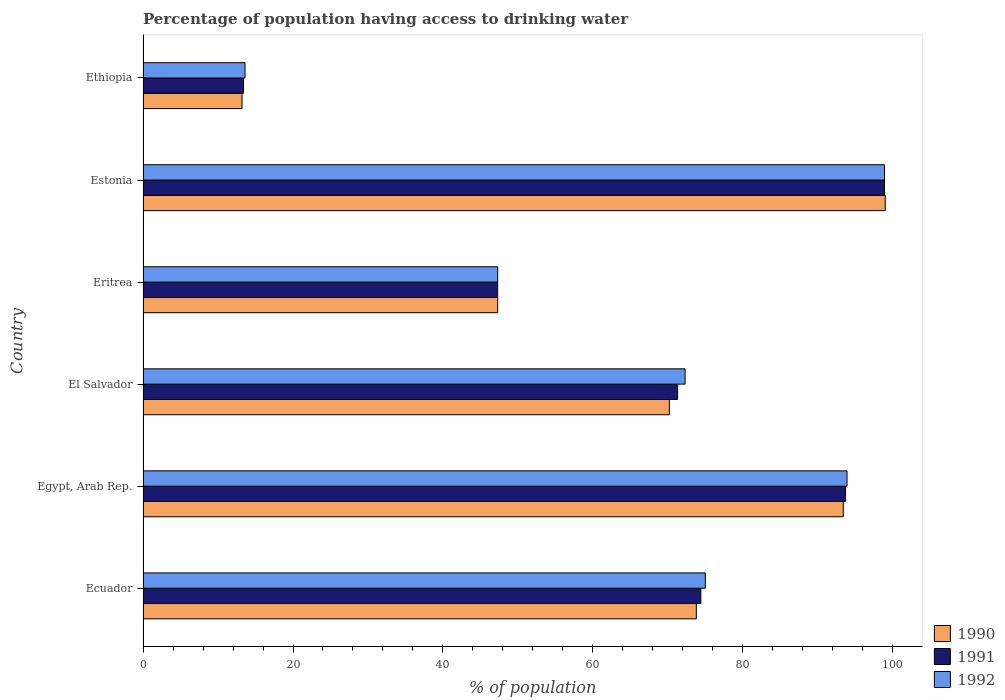How many groups of bars are there?
Give a very brief answer. 6. Are the number of bars per tick equal to the number of legend labels?
Ensure brevity in your answer.  Yes. How many bars are there on the 5th tick from the top?
Provide a succinct answer. 3. What is the label of the 6th group of bars from the top?
Ensure brevity in your answer.  Ecuador. In how many cases, is the number of bars for a given country not equal to the number of legend labels?
Offer a terse response. 0. What is the percentage of population having access to drinking water in 1991 in Estonia?
Your answer should be very brief. 98.9. Across all countries, what is the maximum percentage of population having access to drinking water in 1992?
Your response must be concise. 98.9. Across all countries, what is the minimum percentage of population having access to drinking water in 1990?
Give a very brief answer. 13.2. In which country was the percentage of population having access to drinking water in 1992 maximum?
Offer a terse response. Estonia. In which country was the percentage of population having access to drinking water in 1991 minimum?
Your response must be concise. Ethiopia. What is the total percentage of population having access to drinking water in 1992 in the graph?
Keep it short and to the point. 401. What is the difference between the percentage of population having access to drinking water in 1991 in Ecuador and that in Eritrea?
Offer a terse response. 27.1. What is the difference between the percentage of population having access to drinking water in 1991 in El Salvador and the percentage of population having access to drinking water in 1990 in Ecuador?
Your response must be concise. -2.5. What is the average percentage of population having access to drinking water in 1992 per country?
Your answer should be very brief. 66.83. What is the difference between the percentage of population having access to drinking water in 1990 and percentage of population having access to drinking water in 1992 in Egypt, Arab Rep.?
Make the answer very short. -0.5. In how many countries, is the percentage of population having access to drinking water in 1992 greater than 84 %?
Provide a short and direct response. 2. What is the ratio of the percentage of population having access to drinking water in 1990 in Egypt, Arab Rep. to that in Ethiopia?
Offer a very short reply. 7.08. Is the difference between the percentage of population having access to drinking water in 1990 in El Salvador and Eritrea greater than the difference between the percentage of population having access to drinking water in 1992 in El Salvador and Eritrea?
Offer a very short reply. No. What is the difference between the highest and the lowest percentage of population having access to drinking water in 1992?
Ensure brevity in your answer.  85.3. Are all the bars in the graph horizontal?
Provide a short and direct response. Yes. How many countries are there in the graph?
Your answer should be compact. 6. What is the difference between two consecutive major ticks on the X-axis?
Your answer should be compact. 20. Are the values on the major ticks of X-axis written in scientific E-notation?
Provide a short and direct response. No. Does the graph contain any zero values?
Your response must be concise. No. Does the graph contain grids?
Offer a terse response. No. How many legend labels are there?
Offer a very short reply. 3. What is the title of the graph?
Keep it short and to the point. Percentage of population having access to drinking water. What is the label or title of the X-axis?
Give a very brief answer. % of population. What is the label or title of the Y-axis?
Provide a short and direct response. Country. What is the % of population in 1990 in Ecuador?
Make the answer very short. 73.8. What is the % of population of 1991 in Ecuador?
Give a very brief answer. 74.4. What is the % of population in 1992 in Ecuador?
Offer a very short reply. 75. What is the % of population in 1990 in Egypt, Arab Rep.?
Your answer should be compact. 93.4. What is the % of population of 1991 in Egypt, Arab Rep.?
Offer a terse response. 93.7. What is the % of population in 1992 in Egypt, Arab Rep.?
Give a very brief answer. 93.9. What is the % of population in 1990 in El Salvador?
Provide a short and direct response. 70.2. What is the % of population in 1991 in El Salvador?
Your response must be concise. 71.3. What is the % of population in 1992 in El Salvador?
Provide a short and direct response. 72.3. What is the % of population of 1990 in Eritrea?
Make the answer very short. 47.3. What is the % of population in 1991 in Eritrea?
Offer a terse response. 47.3. What is the % of population in 1992 in Eritrea?
Provide a short and direct response. 47.3. What is the % of population in 1991 in Estonia?
Your response must be concise. 98.9. What is the % of population in 1992 in Estonia?
Make the answer very short. 98.9. What is the % of population of 1990 in Ethiopia?
Your answer should be very brief. 13.2. What is the % of population in 1992 in Ethiopia?
Keep it short and to the point. 13.6. Across all countries, what is the maximum % of population in 1990?
Your answer should be very brief. 99. Across all countries, what is the maximum % of population in 1991?
Offer a terse response. 98.9. Across all countries, what is the maximum % of population in 1992?
Give a very brief answer. 98.9. Across all countries, what is the minimum % of population of 1991?
Your answer should be compact. 13.4. Across all countries, what is the minimum % of population of 1992?
Ensure brevity in your answer.  13.6. What is the total % of population in 1990 in the graph?
Your answer should be compact. 396.9. What is the total % of population in 1991 in the graph?
Provide a succinct answer. 399. What is the total % of population of 1992 in the graph?
Your response must be concise. 401. What is the difference between the % of population in 1990 in Ecuador and that in Egypt, Arab Rep.?
Give a very brief answer. -19.6. What is the difference between the % of population in 1991 in Ecuador and that in Egypt, Arab Rep.?
Ensure brevity in your answer.  -19.3. What is the difference between the % of population in 1992 in Ecuador and that in Egypt, Arab Rep.?
Your response must be concise. -18.9. What is the difference between the % of population of 1991 in Ecuador and that in Eritrea?
Provide a short and direct response. 27.1. What is the difference between the % of population in 1992 in Ecuador and that in Eritrea?
Your answer should be compact. 27.7. What is the difference between the % of population of 1990 in Ecuador and that in Estonia?
Offer a terse response. -25.2. What is the difference between the % of population in 1991 in Ecuador and that in Estonia?
Keep it short and to the point. -24.5. What is the difference between the % of population of 1992 in Ecuador and that in Estonia?
Give a very brief answer. -23.9. What is the difference between the % of population in 1990 in Ecuador and that in Ethiopia?
Provide a short and direct response. 60.6. What is the difference between the % of population in 1992 in Ecuador and that in Ethiopia?
Provide a short and direct response. 61.4. What is the difference between the % of population in 1990 in Egypt, Arab Rep. and that in El Salvador?
Your answer should be compact. 23.2. What is the difference between the % of population of 1991 in Egypt, Arab Rep. and that in El Salvador?
Make the answer very short. 22.4. What is the difference between the % of population in 1992 in Egypt, Arab Rep. and that in El Salvador?
Make the answer very short. 21.6. What is the difference between the % of population in 1990 in Egypt, Arab Rep. and that in Eritrea?
Ensure brevity in your answer.  46.1. What is the difference between the % of population of 1991 in Egypt, Arab Rep. and that in Eritrea?
Offer a very short reply. 46.4. What is the difference between the % of population in 1992 in Egypt, Arab Rep. and that in Eritrea?
Ensure brevity in your answer.  46.6. What is the difference between the % of population of 1991 in Egypt, Arab Rep. and that in Estonia?
Your answer should be very brief. -5.2. What is the difference between the % of population in 1990 in Egypt, Arab Rep. and that in Ethiopia?
Your answer should be compact. 80.2. What is the difference between the % of population in 1991 in Egypt, Arab Rep. and that in Ethiopia?
Provide a succinct answer. 80.3. What is the difference between the % of population in 1992 in Egypt, Arab Rep. and that in Ethiopia?
Offer a terse response. 80.3. What is the difference between the % of population of 1990 in El Salvador and that in Eritrea?
Your answer should be very brief. 22.9. What is the difference between the % of population in 1991 in El Salvador and that in Eritrea?
Offer a very short reply. 24. What is the difference between the % of population of 1992 in El Salvador and that in Eritrea?
Offer a terse response. 25. What is the difference between the % of population in 1990 in El Salvador and that in Estonia?
Offer a terse response. -28.8. What is the difference between the % of population of 1991 in El Salvador and that in Estonia?
Ensure brevity in your answer.  -27.6. What is the difference between the % of population of 1992 in El Salvador and that in Estonia?
Offer a terse response. -26.6. What is the difference between the % of population of 1990 in El Salvador and that in Ethiopia?
Offer a very short reply. 57. What is the difference between the % of population in 1991 in El Salvador and that in Ethiopia?
Keep it short and to the point. 57.9. What is the difference between the % of population of 1992 in El Salvador and that in Ethiopia?
Your answer should be compact. 58.7. What is the difference between the % of population in 1990 in Eritrea and that in Estonia?
Offer a terse response. -51.7. What is the difference between the % of population of 1991 in Eritrea and that in Estonia?
Provide a short and direct response. -51.6. What is the difference between the % of population of 1992 in Eritrea and that in Estonia?
Provide a succinct answer. -51.6. What is the difference between the % of population in 1990 in Eritrea and that in Ethiopia?
Ensure brevity in your answer.  34.1. What is the difference between the % of population of 1991 in Eritrea and that in Ethiopia?
Your response must be concise. 33.9. What is the difference between the % of population of 1992 in Eritrea and that in Ethiopia?
Your answer should be very brief. 33.7. What is the difference between the % of population in 1990 in Estonia and that in Ethiopia?
Your answer should be compact. 85.8. What is the difference between the % of population in 1991 in Estonia and that in Ethiopia?
Your response must be concise. 85.5. What is the difference between the % of population in 1992 in Estonia and that in Ethiopia?
Ensure brevity in your answer.  85.3. What is the difference between the % of population in 1990 in Ecuador and the % of population in 1991 in Egypt, Arab Rep.?
Provide a short and direct response. -19.9. What is the difference between the % of population of 1990 in Ecuador and the % of population of 1992 in Egypt, Arab Rep.?
Your answer should be very brief. -20.1. What is the difference between the % of population in 1991 in Ecuador and the % of population in 1992 in Egypt, Arab Rep.?
Provide a short and direct response. -19.5. What is the difference between the % of population of 1990 in Ecuador and the % of population of 1991 in El Salvador?
Your answer should be very brief. 2.5. What is the difference between the % of population in 1991 in Ecuador and the % of population in 1992 in El Salvador?
Your response must be concise. 2.1. What is the difference between the % of population in 1991 in Ecuador and the % of population in 1992 in Eritrea?
Offer a very short reply. 27.1. What is the difference between the % of population in 1990 in Ecuador and the % of population in 1991 in Estonia?
Your response must be concise. -25.1. What is the difference between the % of population of 1990 in Ecuador and the % of population of 1992 in Estonia?
Keep it short and to the point. -25.1. What is the difference between the % of population in 1991 in Ecuador and the % of population in 1992 in Estonia?
Make the answer very short. -24.5. What is the difference between the % of population of 1990 in Ecuador and the % of population of 1991 in Ethiopia?
Your response must be concise. 60.4. What is the difference between the % of population of 1990 in Ecuador and the % of population of 1992 in Ethiopia?
Ensure brevity in your answer.  60.2. What is the difference between the % of population in 1991 in Ecuador and the % of population in 1992 in Ethiopia?
Give a very brief answer. 60.8. What is the difference between the % of population in 1990 in Egypt, Arab Rep. and the % of population in 1991 in El Salvador?
Provide a short and direct response. 22.1. What is the difference between the % of population in 1990 in Egypt, Arab Rep. and the % of population in 1992 in El Salvador?
Offer a terse response. 21.1. What is the difference between the % of population in 1991 in Egypt, Arab Rep. and the % of population in 1992 in El Salvador?
Ensure brevity in your answer.  21.4. What is the difference between the % of population in 1990 in Egypt, Arab Rep. and the % of population in 1991 in Eritrea?
Offer a terse response. 46.1. What is the difference between the % of population in 1990 in Egypt, Arab Rep. and the % of population in 1992 in Eritrea?
Offer a very short reply. 46.1. What is the difference between the % of population in 1991 in Egypt, Arab Rep. and the % of population in 1992 in Eritrea?
Your response must be concise. 46.4. What is the difference between the % of population of 1990 in Egypt, Arab Rep. and the % of population of 1991 in Estonia?
Keep it short and to the point. -5.5. What is the difference between the % of population in 1990 in Egypt, Arab Rep. and the % of population in 1992 in Estonia?
Your answer should be very brief. -5.5. What is the difference between the % of population of 1990 in Egypt, Arab Rep. and the % of population of 1992 in Ethiopia?
Offer a very short reply. 79.8. What is the difference between the % of population in 1991 in Egypt, Arab Rep. and the % of population in 1992 in Ethiopia?
Offer a terse response. 80.1. What is the difference between the % of population in 1990 in El Salvador and the % of population in 1991 in Eritrea?
Your answer should be compact. 22.9. What is the difference between the % of population in 1990 in El Salvador and the % of population in 1992 in Eritrea?
Provide a succinct answer. 22.9. What is the difference between the % of population of 1991 in El Salvador and the % of population of 1992 in Eritrea?
Your answer should be compact. 24. What is the difference between the % of population in 1990 in El Salvador and the % of population in 1991 in Estonia?
Make the answer very short. -28.7. What is the difference between the % of population in 1990 in El Salvador and the % of population in 1992 in Estonia?
Offer a terse response. -28.7. What is the difference between the % of population in 1991 in El Salvador and the % of population in 1992 in Estonia?
Offer a very short reply. -27.6. What is the difference between the % of population in 1990 in El Salvador and the % of population in 1991 in Ethiopia?
Ensure brevity in your answer.  56.8. What is the difference between the % of population in 1990 in El Salvador and the % of population in 1992 in Ethiopia?
Your answer should be compact. 56.6. What is the difference between the % of population in 1991 in El Salvador and the % of population in 1992 in Ethiopia?
Your response must be concise. 57.7. What is the difference between the % of population in 1990 in Eritrea and the % of population in 1991 in Estonia?
Keep it short and to the point. -51.6. What is the difference between the % of population in 1990 in Eritrea and the % of population in 1992 in Estonia?
Keep it short and to the point. -51.6. What is the difference between the % of population in 1991 in Eritrea and the % of population in 1992 in Estonia?
Offer a terse response. -51.6. What is the difference between the % of population of 1990 in Eritrea and the % of population of 1991 in Ethiopia?
Provide a succinct answer. 33.9. What is the difference between the % of population of 1990 in Eritrea and the % of population of 1992 in Ethiopia?
Provide a short and direct response. 33.7. What is the difference between the % of population of 1991 in Eritrea and the % of population of 1992 in Ethiopia?
Offer a terse response. 33.7. What is the difference between the % of population in 1990 in Estonia and the % of population in 1991 in Ethiopia?
Ensure brevity in your answer.  85.6. What is the difference between the % of population in 1990 in Estonia and the % of population in 1992 in Ethiopia?
Give a very brief answer. 85.4. What is the difference between the % of population of 1991 in Estonia and the % of population of 1992 in Ethiopia?
Give a very brief answer. 85.3. What is the average % of population in 1990 per country?
Offer a very short reply. 66.15. What is the average % of population of 1991 per country?
Offer a terse response. 66.5. What is the average % of population of 1992 per country?
Give a very brief answer. 66.83. What is the difference between the % of population of 1990 and % of population of 1991 in Ecuador?
Offer a very short reply. -0.6. What is the difference between the % of population of 1991 and % of population of 1992 in Ecuador?
Your answer should be compact. -0.6. What is the difference between the % of population in 1990 and % of population in 1991 in Egypt, Arab Rep.?
Give a very brief answer. -0.3. What is the difference between the % of population of 1991 and % of population of 1992 in Egypt, Arab Rep.?
Offer a very short reply. -0.2. What is the difference between the % of population in 1991 and % of population in 1992 in El Salvador?
Your answer should be very brief. -1. What is the difference between the % of population of 1990 and % of population of 1991 in Estonia?
Offer a terse response. 0.1. What is the difference between the % of population in 1991 and % of population in 1992 in Estonia?
Offer a very short reply. 0. What is the difference between the % of population in 1990 and % of population in 1991 in Ethiopia?
Provide a short and direct response. -0.2. What is the difference between the % of population in 1990 and % of population in 1992 in Ethiopia?
Your answer should be compact. -0.4. What is the ratio of the % of population in 1990 in Ecuador to that in Egypt, Arab Rep.?
Offer a terse response. 0.79. What is the ratio of the % of population in 1991 in Ecuador to that in Egypt, Arab Rep.?
Your answer should be very brief. 0.79. What is the ratio of the % of population of 1992 in Ecuador to that in Egypt, Arab Rep.?
Offer a very short reply. 0.8. What is the ratio of the % of population of 1990 in Ecuador to that in El Salvador?
Your answer should be very brief. 1.05. What is the ratio of the % of population of 1991 in Ecuador to that in El Salvador?
Your response must be concise. 1.04. What is the ratio of the % of population in 1992 in Ecuador to that in El Salvador?
Your answer should be compact. 1.04. What is the ratio of the % of population of 1990 in Ecuador to that in Eritrea?
Your answer should be very brief. 1.56. What is the ratio of the % of population in 1991 in Ecuador to that in Eritrea?
Provide a short and direct response. 1.57. What is the ratio of the % of population in 1992 in Ecuador to that in Eritrea?
Offer a terse response. 1.59. What is the ratio of the % of population of 1990 in Ecuador to that in Estonia?
Make the answer very short. 0.75. What is the ratio of the % of population of 1991 in Ecuador to that in Estonia?
Provide a succinct answer. 0.75. What is the ratio of the % of population in 1992 in Ecuador to that in Estonia?
Ensure brevity in your answer.  0.76. What is the ratio of the % of population of 1990 in Ecuador to that in Ethiopia?
Give a very brief answer. 5.59. What is the ratio of the % of population in 1991 in Ecuador to that in Ethiopia?
Your answer should be very brief. 5.55. What is the ratio of the % of population of 1992 in Ecuador to that in Ethiopia?
Provide a short and direct response. 5.51. What is the ratio of the % of population in 1990 in Egypt, Arab Rep. to that in El Salvador?
Keep it short and to the point. 1.33. What is the ratio of the % of population of 1991 in Egypt, Arab Rep. to that in El Salvador?
Keep it short and to the point. 1.31. What is the ratio of the % of population of 1992 in Egypt, Arab Rep. to that in El Salvador?
Offer a very short reply. 1.3. What is the ratio of the % of population of 1990 in Egypt, Arab Rep. to that in Eritrea?
Make the answer very short. 1.97. What is the ratio of the % of population of 1991 in Egypt, Arab Rep. to that in Eritrea?
Offer a very short reply. 1.98. What is the ratio of the % of population in 1992 in Egypt, Arab Rep. to that in Eritrea?
Offer a terse response. 1.99. What is the ratio of the % of population of 1990 in Egypt, Arab Rep. to that in Estonia?
Ensure brevity in your answer.  0.94. What is the ratio of the % of population of 1992 in Egypt, Arab Rep. to that in Estonia?
Offer a terse response. 0.95. What is the ratio of the % of population in 1990 in Egypt, Arab Rep. to that in Ethiopia?
Ensure brevity in your answer.  7.08. What is the ratio of the % of population in 1991 in Egypt, Arab Rep. to that in Ethiopia?
Give a very brief answer. 6.99. What is the ratio of the % of population in 1992 in Egypt, Arab Rep. to that in Ethiopia?
Keep it short and to the point. 6.9. What is the ratio of the % of population in 1990 in El Salvador to that in Eritrea?
Provide a short and direct response. 1.48. What is the ratio of the % of population of 1991 in El Salvador to that in Eritrea?
Give a very brief answer. 1.51. What is the ratio of the % of population of 1992 in El Salvador to that in Eritrea?
Your answer should be very brief. 1.53. What is the ratio of the % of population of 1990 in El Salvador to that in Estonia?
Keep it short and to the point. 0.71. What is the ratio of the % of population of 1991 in El Salvador to that in Estonia?
Your answer should be very brief. 0.72. What is the ratio of the % of population of 1992 in El Salvador to that in Estonia?
Make the answer very short. 0.73. What is the ratio of the % of population of 1990 in El Salvador to that in Ethiopia?
Offer a very short reply. 5.32. What is the ratio of the % of population in 1991 in El Salvador to that in Ethiopia?
Provide a succinct answer. 5.32. What is the ratio of the % of population in 1992 in El Salvador to that in Ethiopia?
Your response must be concise. 5.32. What is the ratio of the % of population in 1990 in Eritrea to that in Estonia?
Offer a very short reply. 0.48. What is the ratio of the % of population in 1991 in Eritrea to that in Estonia?
Provide a short and direct response. 0.48. What is the ratio of the % of population in 1992 in Eritrea to that in Estonia?
Give a very brief answer. 0.48. What is the ratio of the % of population in 1990 in Eritrea to that in Ethiopia?
Provide a succinct answer. 3.58. What is the ratio of the % of population of 1991 in Eritrea to that in Ethiopia?
Keep it short and to the point. 3.53. What is the ratio of the % of population of 1992 in Eritrea to that in Ethiopia?
Provide a succinct answer. 3.48. What is the ratio of the % of population of 1990 in Estonia to that in Ethiopia?
Ensure brevity in your answer.  7.5. What is the ratio of the % of population of 1991 in Estonia to that in Ethiopia?
Ensure brevity in your answer.  7.38. What is the ratio of the % of population in 1992 in Estonia to that in Ethiopia?
Your response must be concise. 7.27. What is the difference between the highest and the second highest % of population in 1991?
Your answer should be very brief. 5.2. What is the difference between the highest and the second highest % of population in 1992?
Give a very brief answer. 5. What is the difference between the highest and the lowest % of population of 1990?
Offer a terse response. 85.8. What is the difference between the highest and the lowest % of population in 1991?
Provide a short and direct response. 85.5. What is the difference between the highest and the lowest % of population in 1992?
Your answer should be compact. 85.3. 